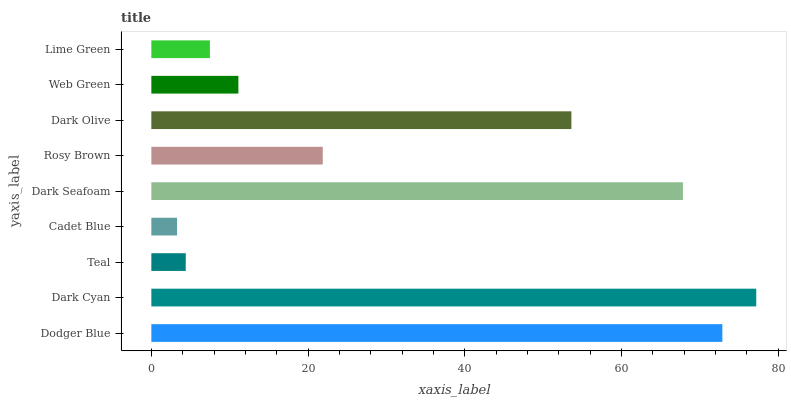Is Cadet Blue the minimum?
Answer yes or no. Yes. Is Dark Cyan the maximum?
Answer yes or no. Yes. Is Teal the minimum?
Answer yes or no. No. Is Teal the maximum?
Answer yes or no. No. Is Dark Cyan greater than Teal?
Answer yes or no. Yes. Is Teal less than Dark Cyan?
Answer yes or no. Yes. Is Teal greater than Dark Cyan?
Answer yes or no. No. Is Dark Cyan less than Teal?
Answer yes or no. No. Is Rosy Brown the high median?
Answer yes or no. Yes. Is Rosy Brown the low median?
Answer yes or no. Yes. Is Dark Seafoam the high median?
Answer yes or no. No. Is Dark Olive the low median?
Answer yes or no. No. 